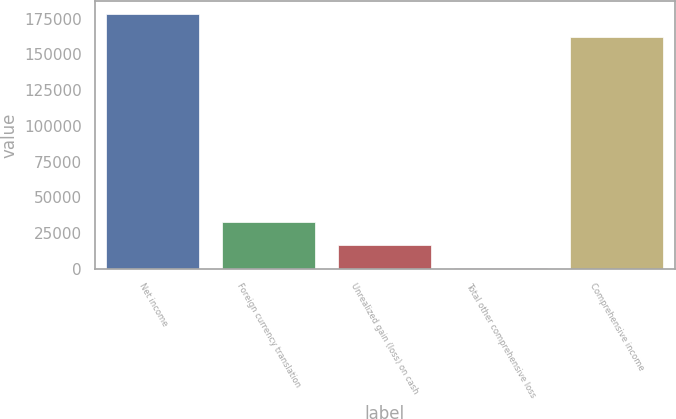Convert chart. <chart><loc_0><loc_0><loc_500><loc_500><bar_chart><fcel>Net income<fcel>Foreign currency translation<fcel>Unrealized gain (loss) on cash<fcel>Total other comprehensive loss<fcel>Comprehensive income<nl><fcel>178372<fcel>32605.2<fcel>16389.6<fcel>174<fcel>162156<nl></chart> 